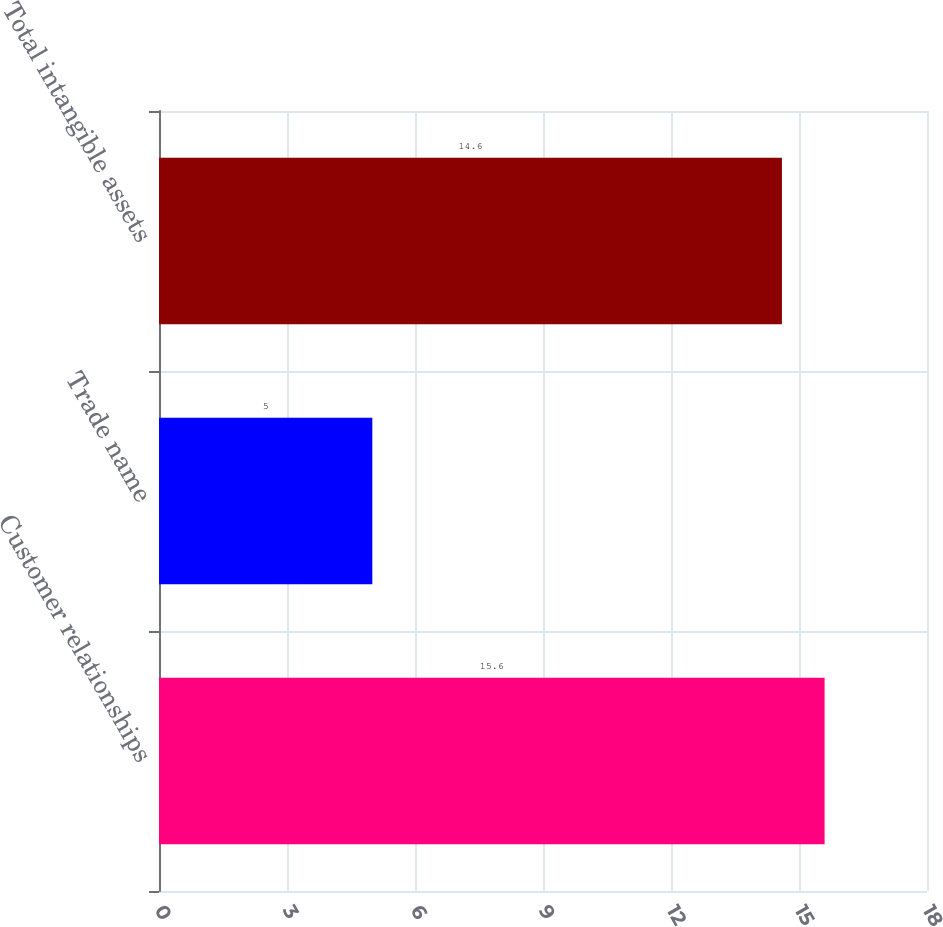Convert chart to OTSL. <chart><loc_0><loc_0><loc_500><loc_500><bar_chart><fcel>Customer relationships<fcel>Trade name<fcel>Total intangible assets<nl><fcel>15.6<fcel>5<fcel>14.6<nl></chart> 